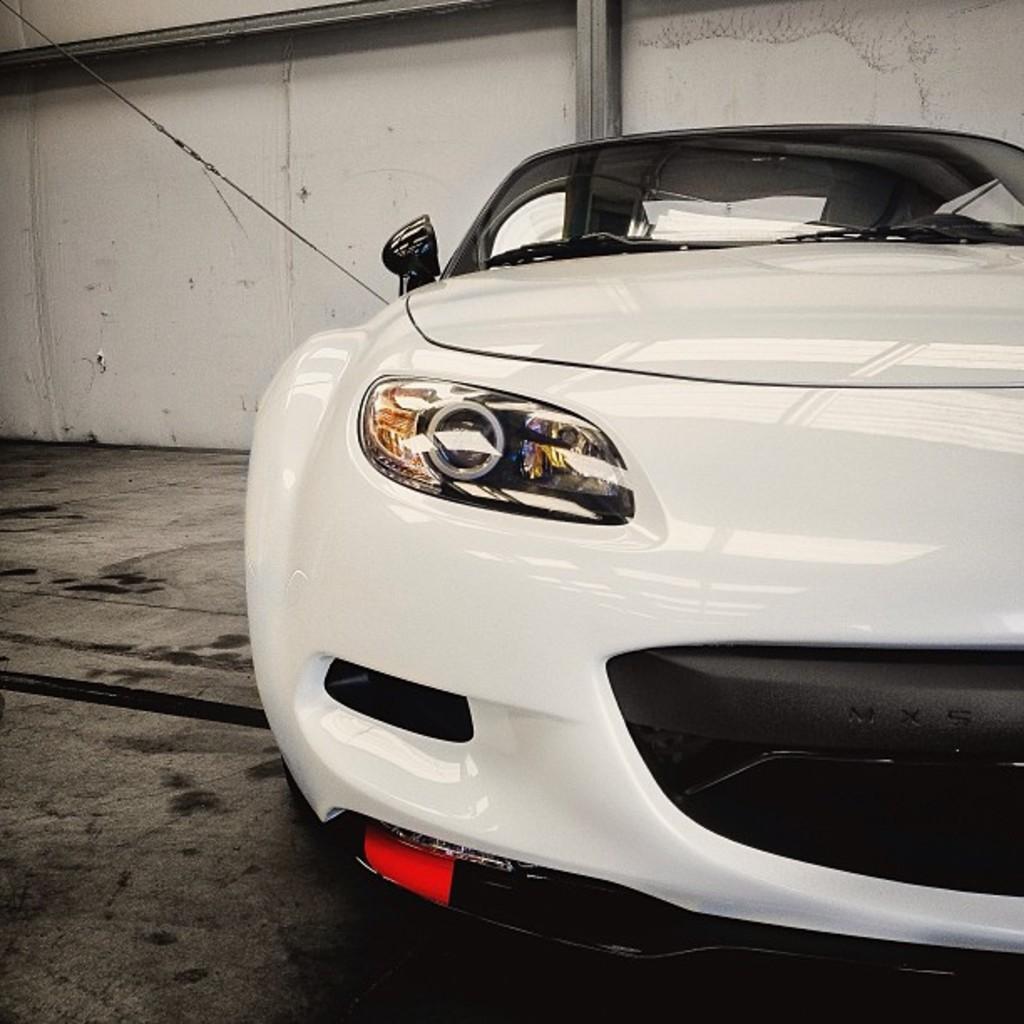Can you describe this image briefly? This picture is clicked inside. On the right there is a white color car parked on the ground. In the background we can see a cable, wall and the metal rods. 